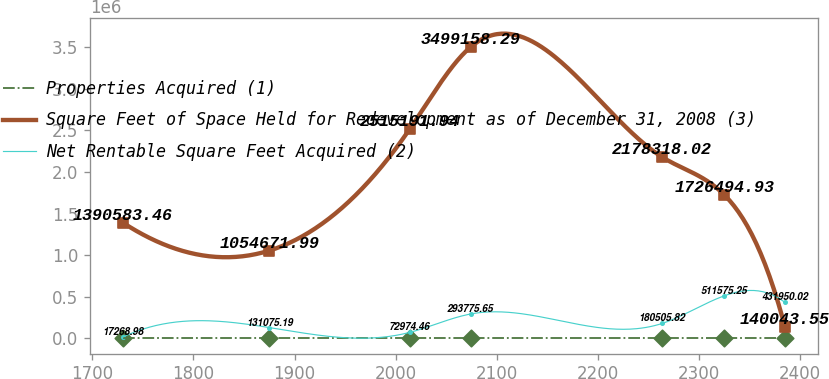<chart> <loc_0><loc_0><loc_500><loc_500><line_chart><ecel><fcel>Properties Acquired (1)<fcel>Square Feet of Space Held for Redevelopment as of December 31, 2008 (3)<fcel>Net Rentable Square Feet Acquired (2)<nl><fcel>1730.12<fcel>5.77<fcel>1.39058e+06<fcel>17269<nl><fcel>1875<fcel>7.07<fcel>1.05467e+06<fcel>131075<nl><fcel>2014.04<fcel>9.9<fcel>2.51519e+06<fcel>72974.5<nl><fcel>2074.24<fcel>17.33<fcel>3.49916e+06<fcel>293776<nl><fcel>2263.87<fcel>18.63<fcel>2.17832e+06<fcel>180506<nl><fcel>2325.22<fcel>12.78<fcel>1.72649e+06<fcel>511575<nl><fcel>2385.42<fcel>4.47<fcel>140044<fcel>431950<nl></chart> 